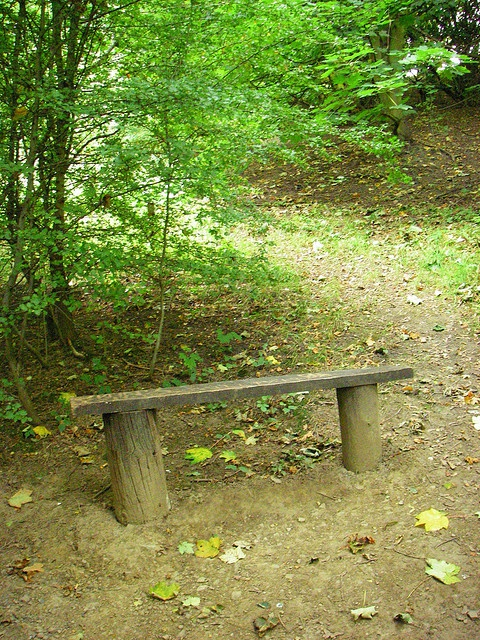Describe the objects in this image and their specific colors. I can see a bench in green, olive, gray, and tan tones in this image. 